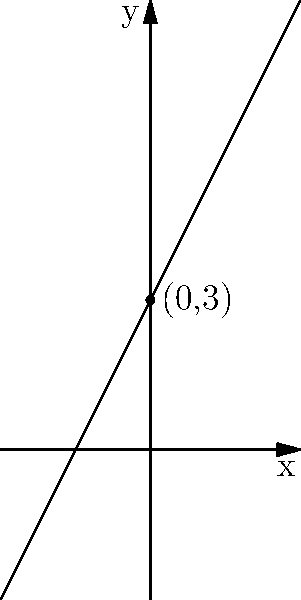Looking at the graph of a straight line, can you identify the point where it crosses the y-axis? This point is called the y-intercept and is important for understanding your daily blood sugar levels. Let's approach this step-by-step:

1. The y-intercept is the point where a line crosses the y-axis.
2. The y-axis is the vertical line that goes through the point (0,0).
3. On this graph, we can see a dot marked where the line crosses the y-axis.
4. This dot is labeled "(0,3)".
5. The first number in the coordinate (0,3) tells us it's on the y-axis (x = 0).
6. The second number tells us how high up the y-axis the point is (y = 3).

Therefore, the y-intercept of this line is the point (0,3).

In terms of blood sugar levels, the y-intercept could represent your baseline blood sugar level before any factors (like food or exercise) affect it.
Answer: (0,3) 